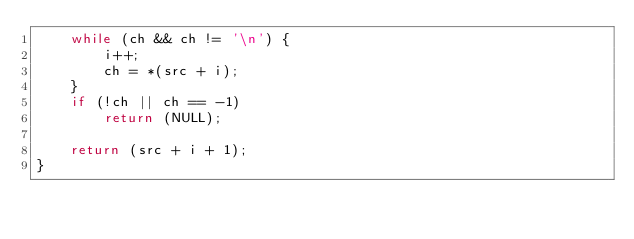Convert code to text. <code><loc_0><loc_0><loc_500><loc_500><_C_>	while (ch && ch != '\n') {
		i++;
		ch = *(src + i);
	}
	if (!ch || ch == -1)
		return (NULL);

	return (src + i + 1);
}

</code> 